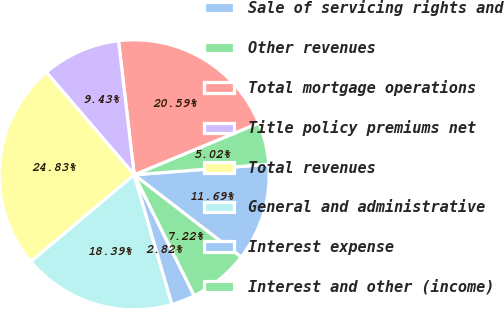Convert chart. <chart><loc_0><loc_0><loc_500><loc_500><pie_chart><fcel>Sale of servicing rights and<fcel>Other revenues<fcel>Total mortgage operations<fcel>Title policy premiums net<fcel>Total revenues<fcel>General and administrative<fcel>Interest expense<fcel>Interest and other (income)<nl><fcel>11.69%<fcel>5.02%<fcel>20.59%<fcel>9.43%<fcel>24.83%<fcel>18.39%<fcel>2.82%<fcel>7.22%<nl></chart> 